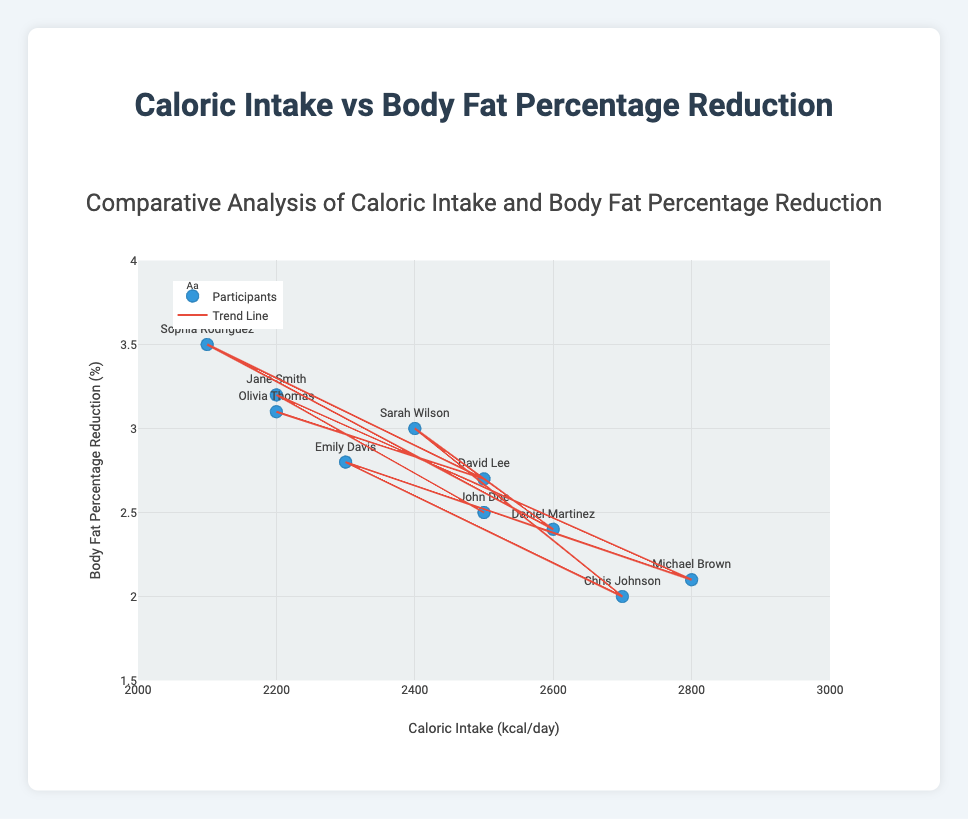What is the title of the scatter plot? The title is displayed at the top of the figure. It reads "Comparative Analysis of Caloric Intake and Body Fat Percentage Reduction".
Answer: Comparative Analysis of Caloric Intake and Body Fat Percentage Reduction How many participants are represented in the scatter plot? Count the number of unique data points in the figure. Each marker corresponds to one participant. There are 10 markers visible on the plot.
Answer: 10 What is the range of the x-axis in the scatter plot? The x-axis represents Caloric Intake (kcal/day) and has a range from 2000 to 3000, which is seen by looking at the start and end points of the axis.
Answer: 2000 to 3000 What is the range of the y-axis in the scatter plot? The y-axis represents Body Fat Percentage Reduction (%) and has a range from 1.5 to 4. This is marked on the y-axis start and end points.
Answer: 1.5 to 4 Which participant has the highest body fat percentage reduction? Identify the Y-value that is the highest (the topmost point). Sophia Rodriguez, with 3.5%, has the highest reduction.
Answer: Sophia Rodriguez What is the relationship between caloric intake and body fat percentage reduction? The figure includes a trend line. By examining the direction and slope of the trend line, it indicates the relationship: as caloric intake increases, body fat percentage reduction tends to decrease.
Answer: Inversely related What is the average caloric intake of the participants? Sum the caloric intake of all participants: (2500 + 2200 + 2800 + 2300 + 2700 + 2400 + 2600 + 2100 + 2500 + 2200) = 24300. Divide by the number of participants, which is 10. The average caloric intake is 2430 kcal/day.
Answer: 2430 kcal/day Which participant had a body fat percentage reduction exactly at 2.5% and what was their caloric intake? Find the data point where the y-value is 2.5%. The participant is John Doe, with a caloric intake of 2500 kcal/day.
Answer: John Doe, 2500 kcal/day Comparing John Doe and Jane Smith, who had a higher body fat percentage reduction? John Doe's reduction is 2.5%, while Jane Smith's is 3.2%. Thus, Jane Smith had a higher reduction.
Answer: Jane Smith Which participant had the lowest caloric intake and what was their body fat percentage reduction? The lowest caloric intake is 2100 kcal/day by Sophia Rodriguez, with a body fat percentage reduction of 3.5%.
Answer: Sophia Rodriguez, 3.5% 